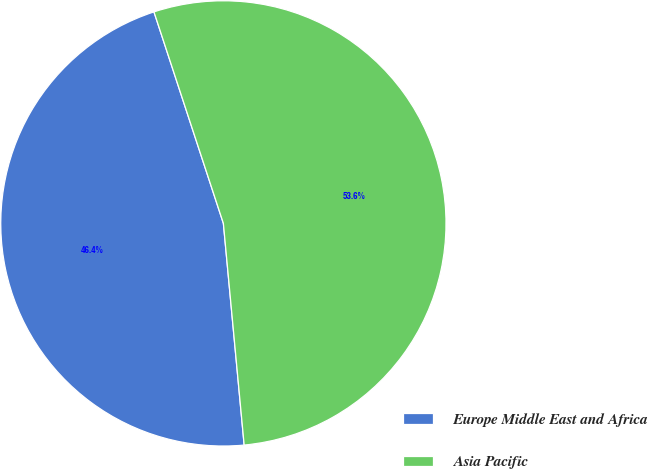<chart> <loc_0><loc_0><loc_500><loc_500><pie_chart><fcel>Europe Middle East and Africa<fcel>Asia Pacific<nl><fcel>46.44%<fcel>53.56%<nl></chart> 